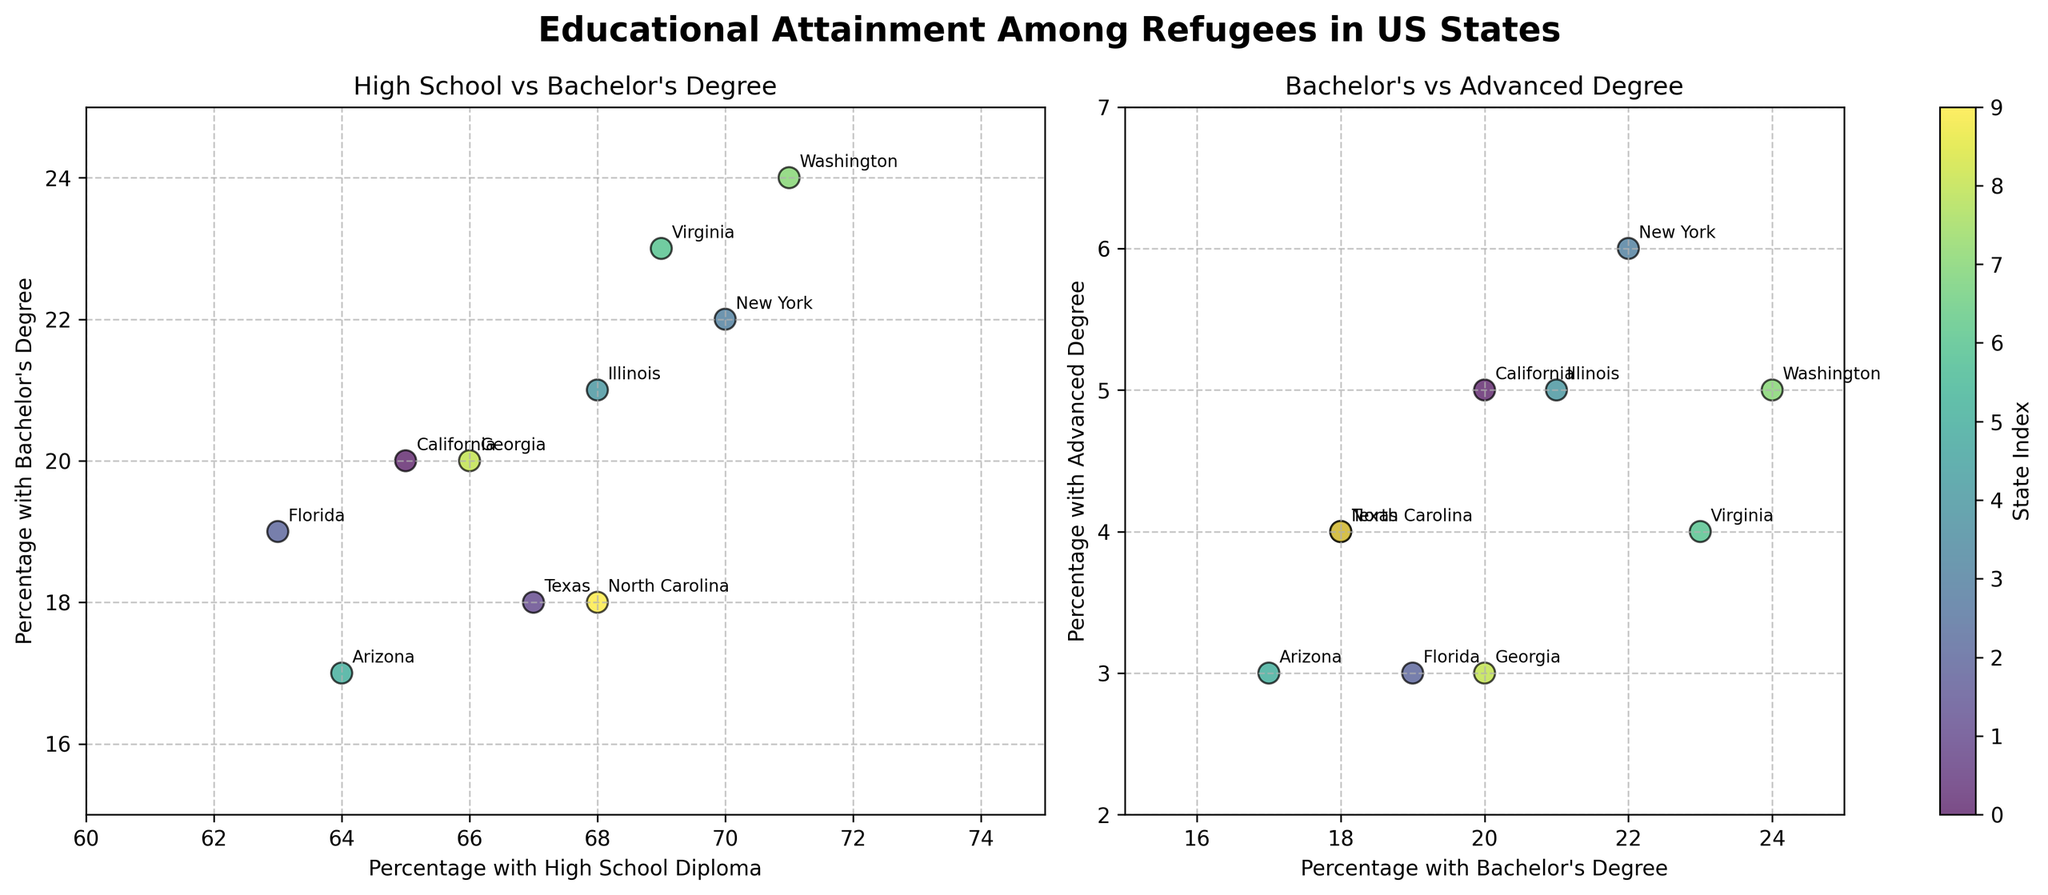What is the title of the figure? The title is displayed at the top of the figure in bold font. It reads "Educational Attainment Among Refugees in US States."
Answer: Educational Attainment Among Refugees in US States Which state has the highest percentage of refugees with a high school diploma? By inspecting the scatter plot on the left, Washington has the highest percentage of refugees with a high school diploma at 71%.
Answer: Washington Which two states have a 67% rate of refugees with high school diplomas? The scatter plot on the left shows Texas and North Carolina both have 67% of refugees with high school diplomas.
Answer: Texas and North Carolina What is the range of percentages for refugees with advanced degrees? The scatter plot on the right shows that the lowest and highest percentages for advanced degrees are 2% and 6% respectively.
Answer: 2% to 6% What is the percentage of refugees with bachelor's degrees in Florida and Georgia? By looking at the scatter plot on the left, Florida has 19% and Georgia has 20% of refugees with bachelor's degrees.
Answer: Florida: 19%, Georgia: 20% How does the percentage of refugees with bachelor's degrees compare between New York and California? In the left scatter plot, New York has 22% and California has 20% of refugees with bachelor's degrees, so New York has a 2% higher percentage.
Answer: New York has 2% more What is the average percentage of refugees with advanced degrees across all states? To calculate, sum the percentages of advanced degrees across all states (5+4+3+6+5+3+4+5+3+4 = 42) and divide by the number of states (10). The average is 42/10 = 4.2%.
Answer: 4.2% Which state has the lowest percentage of refugees with bachelor's degrees? In the scatter plot on the left, Arizona has the lowest percentage of refugees with bachelor's degrees at 17%.
Answer: Arizona Is there a state that has more than 20% of refugees with both bachelor's and advanced degrees? Check the points on the right scatter plot; Washington has 24% with bachelor's and 5% with advanced degrees which satisfies this condition.
Answer: Washington 